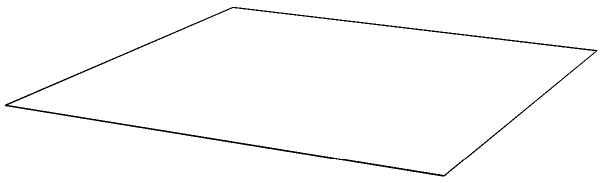Calculate the surface area of a regular octahedron with edge length $a = 2$ units. To calculate the surface area of a regular octahedron:

1) A regular octahedron has 8 congruent equilateral triangular faces.

2) The area of one equilateral triangle with side length $a$ is:
   $$A_{\text{triangle}} = \frac{\sqrt{3}}{4}a^2$$

3) For the given octahedron with $a = 2$:
   $$A_{\text{triangle}} = \frac{\sqrt{3}}{4}(2^2) = \sqrt{3}$$

4) The total surface area is 8 times the area of one triangle:
   $$A_{\text{total}} = 8 \cdot A_{\text{triangle}} = 8\sqrt{3}$$

Therefore, the surface area of the regular octahedron is $8\sqrt{3}$ square units.
Answer: $8\sqrt{3}$ square units 